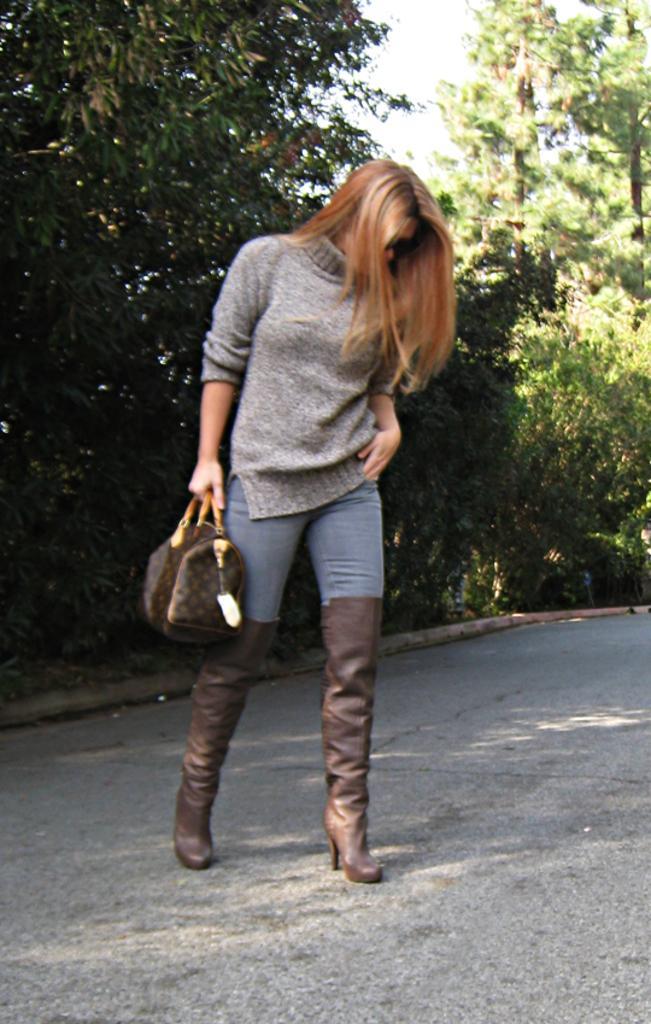In one or two sentences, can you explain what this image depicts? In this picture we can see a woman standing on road and aside to this road we have trees and this woman is carrying a bag and she wore shoes. 